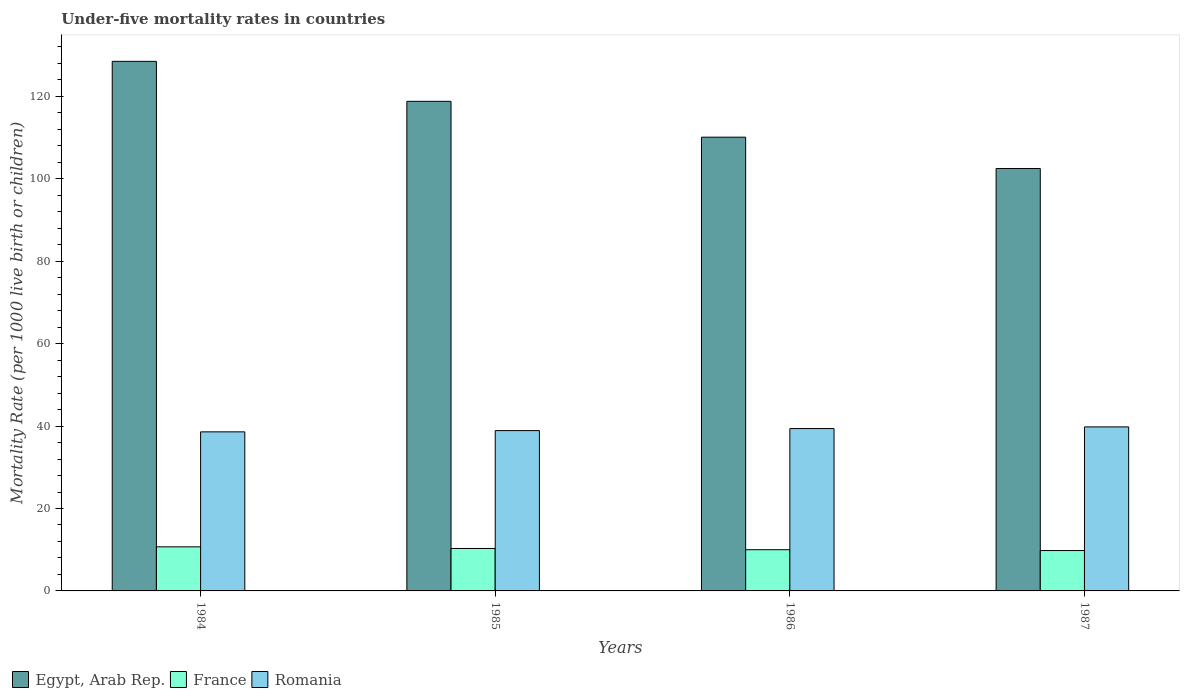How many different coloured bars are there?
Give a very brief answer. 3. How many groups of bars are there?
Offer a terse response. 4. Are the number of bars on each tick of the X-axis equal?
Provide a succinct answer. Yes. How many bars are there on the 1st tick from the right?
Give a very brief answer. 3. What is the label of the 2nd group of bars from the left?
Your answer should be compact. 1985. Across all years, what is the minimum under-five mortality rate in Romania?
Your answer should be compact. 38.6. In which year was the under-five mortality rate in France maximum?
Your answer should be very brief. 1984. In which year was the under-five mortality rate in Romania minimum?
Your answer should be compact. 1984. What is the total under-five mortality rate in Romania in the graph?
Keep it short and to the point. 156.7. What is the difference between the under-five mortality rate in Romania in 1985 and that in 1987?
Your answer should be very brief. -0.9. What is the difference between the under-five mortality rate in Egypt, Arab Rep. in 1986 and the under-five mortality rate in Romania in 1984?
Provide a short and direct response. 71.5. What is the average under-five mortality rate in Egypt, Arab Rep. per year?
Your answer should be compact. 114.97. In the year 1984, what is the difference between the under-five mortality rate in Romania and under-five mortality rate in France?
Provide a succinct answer. 27.9. What is the ratio of the under-five mortality rate in Romania in 1984 to that in 1985?
Offer a very short reply. 0.99. Is the difference between the under-five mortality rate in Romania in 1986 and 1987 greater than the difference between the under-five mortality rate in France in 1986 and 1987?
Your response must be concise. No. What is the difference between the highest and the second highest under-five mortality rate in Romania?
Your answer should be very brief. 0.4. What is the difference between the highest and the lowest under-five mortality rate in Romania?
Your answer should be compact. 1.2. In how many years, is the under-five mortality rate in France greater than the average under-five mortality rate in France taken over all years?
Provide a succinct answer. 2. Is the sum of the under-five mortality rate in Romania in 1984 and 1987 greater than the maximum under-five mortality rate in France across all years?
Your answer should be very brief. Yes. What does the 3rd bar from the left in 1985 represents?
Offer a terse response. Romania. What does the 1st bar from the right in 1986 represents?
Your answer should be very brief. Romania. How many years are there in the graph?
Keep it short and to the point. 4. Where does the legend appear in the graph?
Your response must be concise. Bottom left. How many legend labels are there?
Keep it short and to the point. 3. How are the legend labels stacked?
Keep it short and to the point. Horizontal. What is the title of the graph?
Ensure brevity in your answer.  Under-five mortality rates in countries. Does "Zimbabwe" appear as one of the legend labels in the graph?
Make the answer very short. No. What is the label or title of the X-axis?
Keep it short and to the point. Years. What is the label or title of the Y-axis?
Make the answer very short. Mortality Rate (per 1000 live birth or children). What is the Mortality Rate (per 1000 live birth or children) of Egypt, Arab Rep. in 1984?
Provide a succinct answer. 128.5. What is the Mortality Rate (per 1000 live birth or children) in Romania in 1984?
Offer a terse response. 38.6. What is the Mortality Rate (per 1000 live birth or children) in Egypt, Arab Rep. in 1985?
Keep it short and to the point. 118.8. What is the Mortality Rate (per 1000 live birth or children) in France in 1985?
Give a very brief answer. 10.3. What is the Mortality Rate (per 1000 live birth or children) in Romania in 1985?
Your answer should be compact. 38.9. What is the Mortality Rate (per 1000 live birth or children) in Egypt, Arab Rep. in 1986?
Offer a terse response. 110.1. What is the Mortality Rate (per 1000 live birth or children) of Romania in 1986?
Keep it short and to the point. 39.4. What is the Mortality Rate (per 1000 live birth or children) in Egypt, Arab Rep. in 1987?
Give a very brief answer. 102.5. What is the Mortality Rate (per 1000 live birth or children) of France in 1987?
Give a very brief answer. 9.8. What is the Mortality Rate (per 1000 live birth or children) of Romania in 1987?
Your answer should be compact. 39.8. Across all years, what is the maximum Mortality Rate (per 1000 live birth or children) in Egypt, Arab Rep.?
Make the answer very short. 128.5. Across all years, what is the maximum Mortality Rate (per 1000 live birth or children) in Romania?
Offer a very short reply. 39.8. Across all years, what is the minimum Mortality Rate (per 1000 live birth or children) of Egypt, Arab Rep.?
Provide a short and direct response. 102.5. Across all years, what is the minimum Mortality Rate (per 1000 live birth or children) of France?
Your answer should be compact. 9.8. Across all years, what is the minimum Mortality Rate (per 1000 live birth or children) in Romania?
Give a very brief answer. 38.6. What is the total Mortality Rate (per 1000 live birth or children) in Egypt, Arab Rep. in the graph?
Your answer should be compact. 459.9. What is the total Mortality Rate (per 1000 live birth or children) in France in the graph?
Provide a short and direct response. 40.8. What is the total Mortality Rate (per 1000 live birth or children) of Romania in the graph?
Provide a succinct answer. 156.7. What is the difference between the Mortality Rate (per 1000 live birth or children) in France in 1984 and that in 1985?
Make the answer very short. 0.4. What is the difference between the Mortality Rate (per 1000 live birth or children) in Romania in 1984 and that in 1985?
Provide a succinct answer. -0.3. What is the difference between the Mortality Rate (per 1000 live birth or children) of Egypt, Arab Rep. in 1984 and that in 1986?
Offer a very short reply. 18.4. What is the difference between the Mortality Rate (per 1000 live birth or children) in France in 1984 and that in 1986?
Your response must be concise. 0.7. What is the difference between the Mortality Rate (per 1000 live birth or children) in Romania in 1984 and that in 1986?
Keep it short and to the point. -0.8. What is the difference between the Mortality Rate (per 1000 live birth or children) in Egypt, Arab Rep. in 1984 and that in 1987?
Your answer should be compact. 26. What is the difference between the Mortality Rate (per 1000 live birth or children) of France in 1984 and that in 1987?
Your answer should be very brief. 0.9. What is the difference between the Mortality Rate (per 1000 live birth or children) of Romania in 1985 and that in 1986?
Ensure brevity in your answer.  -0.5. What is the difference between the Mortality Rate (per 1000 live birth or children) of Egypt, Arab Rep. in 1986 and that in 1987?
Your answer should be compact. 7.6. What is the difference between the Mortality Rate (per 1000 live birth or children) in France in 1986 and that in 1987?
Your answer should be very brief. 0.2. What is the difference between the Mortality Rate (per 1000 live birth or children) in Egypt, Arab Rep. in 1984 and the Mortality Rate (per 1000 live birth or children) in France in 1985?
Your response must be concise. 118.2. What is the difference between the Mortality Rate (per 1000 live birth or children) of Egypt, Arab Rep. in 1984 and the Mortality Rate (per 1000 live birth or children) of Romania in 1985?
Offer a terse response. 89.6. What is the difference between the Mortality Rate (per 1000 live birth or children) in France in 1984 and the Mortality Rate (per 1000 live birth or children) in Romania in 1985?
Ensure brevity in your answer.  -28.2. What is the difference between the Mortality Rate (per 1000 live birth or children) in Egypt, Arab Rep. in 1984 and the Mortality Rate (per 1000 live birth or children) in France in 1986?
Your answer should be compact. 118.5. What is the difference between the Mortality Rate (per 1000 live birth or children) of Egypt, Arab Rep. in 1984 and the Mortality Rate (per 1000 live birth or children) of Romania in 1986?
Provide a succinct answer. 89.1. What is the difference between the Mortality Rate (per 1000 live birth or children) in France in 1984 and the Mortality Rate (per 1000 live birth or children) in Romania in 1986?
Ensure brevity in your answer.  -28.7. What is the difference between the Mortality Rate (per 1000 live birth or children) in Egypt, Arab Rep. in 1984 and the Mortality Rate (per 1000 live birth or children) in France in 1987?
Your response must be concise. 118.7. What is the difference between the Mortality Rate (per 1000 live birth or children) of Egypt, Arab Rep. in 1984 and the Mortality Rate (per 1000 live birth or children) of Romania in 1987?
Your answer should be very brief. 88.7. What is the difference between the Mortality Rate (per 1000 live birth or children) of France in 1984 and the Mortality Rate (per 1000 live birth or children) of Romania in 1987?
Offer a terse response. -29.1. What is the difference between the Mortality Rate (per 1000 live birth or children) of Egypt, Arab Rep. in 1985 and the Mortality Rate (per 1000 live birth or children) of France in 1986?
Ensure brevity in your answer.  108.8. What is the difference between the Mortality Rate (per 1000 live birth or children) of Egypt, Arab Rep. in 1985 and the Mortality Rate (per 1000 live birth or children) of Romania in 1986?
Keep it short and to the point. 79.4. What is the difference between the Mortality Rate (per 1000 live birth or children) in France in 1985 and the Mortality Rate (per 1000 live birth or children) in Romania in 1986?
Keep it short and to the point. -29.1. What is the difference between the Mortality Rate (per 1000 live birth or children) of Egypt, Arab Rep. in 1985 and the Mortality Rate (per 1000 live birth or children) of France in 1987?
Provide a succinct answer. 109. What is the difference between the Mortality Rate (per 1000 live birth or children) of Egypt, Arab Rep. in 1985 and the Mortality Rate (per 1000 live birth or children) of Romania in 1987?
Your response must be concise. 79. What is the difference between the Mortality Rate (per 1000 live birth or children) in France in 1985 and the Mortality Rate (per 1000 live birth or children) in Romania in 1987?
Your answer should be compact. -29.5. What is the difference between the Mortality Rate (per 1000 live birth or children) in Egypt, Arab Rep. in 1986 and the Mortality Rate (per 1000 live birth or children) in France in 1987?
Ensure brevity in your answer.  100.3. What is the difference between the Mortality Rate (per 1000 live birth or children) in Egypt, Arab Rep. in 1986 and the Mortality Rate (per 1000 live birth or children) in Romania in 1987?
Make the answer very short. 70.3. What is the difference between the Mortality Rate (per 1000 live birth or children) in France in 1986 and the Mortality Rate (per 1000 live birth or children) in Romania in 1987?
Make the answer very short. -29.8. What is the average Mortality Rate (per 1000 live birth or children) of Egypt, Arab Rep. per year?
Keep it short and to the point. 114.97. What is the average Mortality Rate (per 1000 live birth or children) of Romania per year?
Your answer should be very brief. 39.17. In the year 1984, what is the difference between the Mortality Rate (per 1000 live birth or children) of Egypt, Arab Rep. and Mortality Rate (per 1000 live birth or children) of France?
Offer a terse response. 117.8. In the year 1984, what is the difference between the Mortality Rate (per 1000 live birth or children) in Egypt, Arab Rep. and Mortality Rate (per 1000 live birth or children) in Romania?
Provide a succinct answer. 89.9. In the year 1984, what is the difference between the Mortality Rate (per 1000 live birth or children) in France and Mortality Rate (per 1000 live birth or children) in Romania?
Provide a succinct answer. -27.9. In the year 1985, what is the difference between the Mortality Rate (per 1000 live birth or children) in Egypt, Arab Rep. and Mortality Rate (per 1000 live birth or children) in France?
Ensure brevity in your answer.  108.5. In the year 1985, what is the difference between the Mortality Rate (per 1000 live birth or children) in Egypt, Arab Rep. and Mortality Rate (per 1000 live birth or children) in Romania?
Your answer should be very brief. 79.9. In the year 1985, what is the difference between the Mortality Rate (per 1000 live birth or children) in France and Mortality Rate (per 1000 live birth or children) in Romania?
Make the answer very short. -28.6. In the year 1986, what is the difference between the Mortality Rate (per 1000 live birth or children) in Egypt, Arab Rep. and Mortality Rate (per 1000 live birth or children) in France?
Give a very brief answer. 100.1. In the year 1986, what is the difference between the Mortality Rate (per 1000 live birth or children) in Egypt, Arab Rep. and Mortality Rate (per 1000 live birth or children) in Romania?
Make the answer very short. 70.7. In the year 1986, what is the difference between the Mortality Rate (per 1000 live birth or children) in France and Mortality Rate (per 1000 live birth or children) in Romania?
Your answer should be compact. -29.4. In the year 1987, what is the difference between the Mortality Rate (per 1000 live birth or children) in Egypt, Arab Rep. and Mortality Rate (per 1000 live birth or children) in France?
Offer a very short reply. 92.7. In the year 1987, what is the difference between the Mortality Rate (per 1000 live birth or children) in Egypt, Arab Rep. and Mortality Rate (per 1000 live birth or children) in Romania?
Give a very brief answer. 62.7. In the year 1987, what is the difference between the Mortality Rate (per 1000 live birth or children) of France and Mortality Rate (per 1000 live birth or children) of Romania?
Provide a succinct answer. -30. What is the ratio of the Mortality Rate (per 1000 live birth or children) in Egypt, Arab Rep. in 1984 to that in 1985?
Ensure brevity in your answer.  1.08. What is the ratio of the Mortality Rate (per 1000 live birth or children) of France in 1984 to that in 1985?
Your answer should be compact. 1.04. What is the ratio of the Mortality Rate (per 1000 live birth or children) in Romania in 1984 to that in 1985?
Your response must be concise. 0.99. What is the ratio of the Mortality Rate (per 1000 live birth or children) in Egypt, Arab Rep. in 1984 to that in 1986?
Your response must be concise. 1.17. What is the ratio of the Mortality Rate (per 1000 live birth or children) in France in 1984 to that in 1986?
Ensure brevity in your answer.  1.07. What is the ratio of the Mortality Rate (per 1000 live birth or children) of Romania in 1984 to that in 1986?
Your answer should be compact. 0.98. What is the ratio of the Mortality Rate (per 1000 live birth or children) in Egypt, Arab Rep. in 1984 to that in 1987?
Your answer should be very brief. 1.25. What is the ratio of the Mortality Rate (per 1000 live birth or children) in France in 1984 to that in 1987?
Your answer should be compact. 1.09. What is the ratio of the Mortality Rate (per 1000 live birth or children) of Romania in 1984 to that in 1987?
Keep it short and to the point. 0.97. What is the ratio of the Mortality Rate (per 1000 live birth or children) in Egypt, Arab Rep. in 1985 to that in 1986?
Your answer should be very brief. 1.08. What is the ratio of the Mortality Rate (per 1000 live birth or children) in Romania in 1985 to that in 1986?
Provide a succinct answer. 0.99. What is the ratio of the Mortality Rate (per 1000 live birth or children) of Egypt, Arab Rep. in 1985 to that in 1987?
Offer a very short reply. 1.16. What is the ratio of the Mortality Rate (per 1000 live birth or children) of France in 1985 to that in 1987?
Your answer should be very brief. 1.05. What is the ratio of the Mortality Rate (per 1000 live birth or children) of Romania in 1985 to that in 1987?
Give a very brief answer. 0.98. What is the ratio of the Mortality Rate (per 1000 live birth or children) in Egypt, Arab Rep. in 1986 to that in 1987?
Keep it short and to the point. 1.07. What is the ratio of the Mortality Rate (per 1000 live birth or children) of France in 1986 to that in 1987?
Your response must be concise. 1.02. What is the difference between the highest and the second highest Mortality Rate (per 1000 live birth or children) of Egypt, Arab Rep.?
Provide a succinct answer. 9.7. What is the difference between the highest and the second highest Mortality Rate (per 1000 live birth or children) of France?
Your answer should be compact. 0.4. What is the difference between the highest and the lowest Mortality Rate (per 1000 live birth or children) in Egypt, Arab Rep.?
Your answer should be compact. 26. 